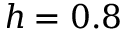Convert formula to latex. <formula><loc_0><loc_0><loc_500><loc_500>h = 0 . 8</formula> 